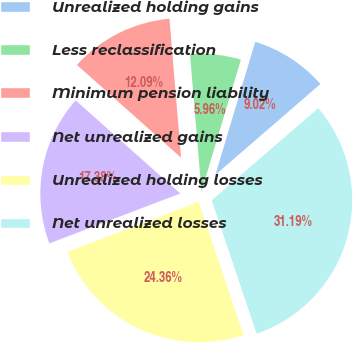Convert chart to OTSL. <chart><loc_0><loc_0><loc_500><loc_500><pie_chart><fcel>Unrealized holding gains<fcel>Less reclassification<fcel>Minimum pension liability<fcel>Net unrealized gains<fcel>Unrealized holding losses<fcel>Net unrealized losses<nl><fcel>9.02%<fcel>5.96%<fcel>12.09%<fcel>17.38%<fcel>24.36%<fcel>31.19%<nl></chart> 